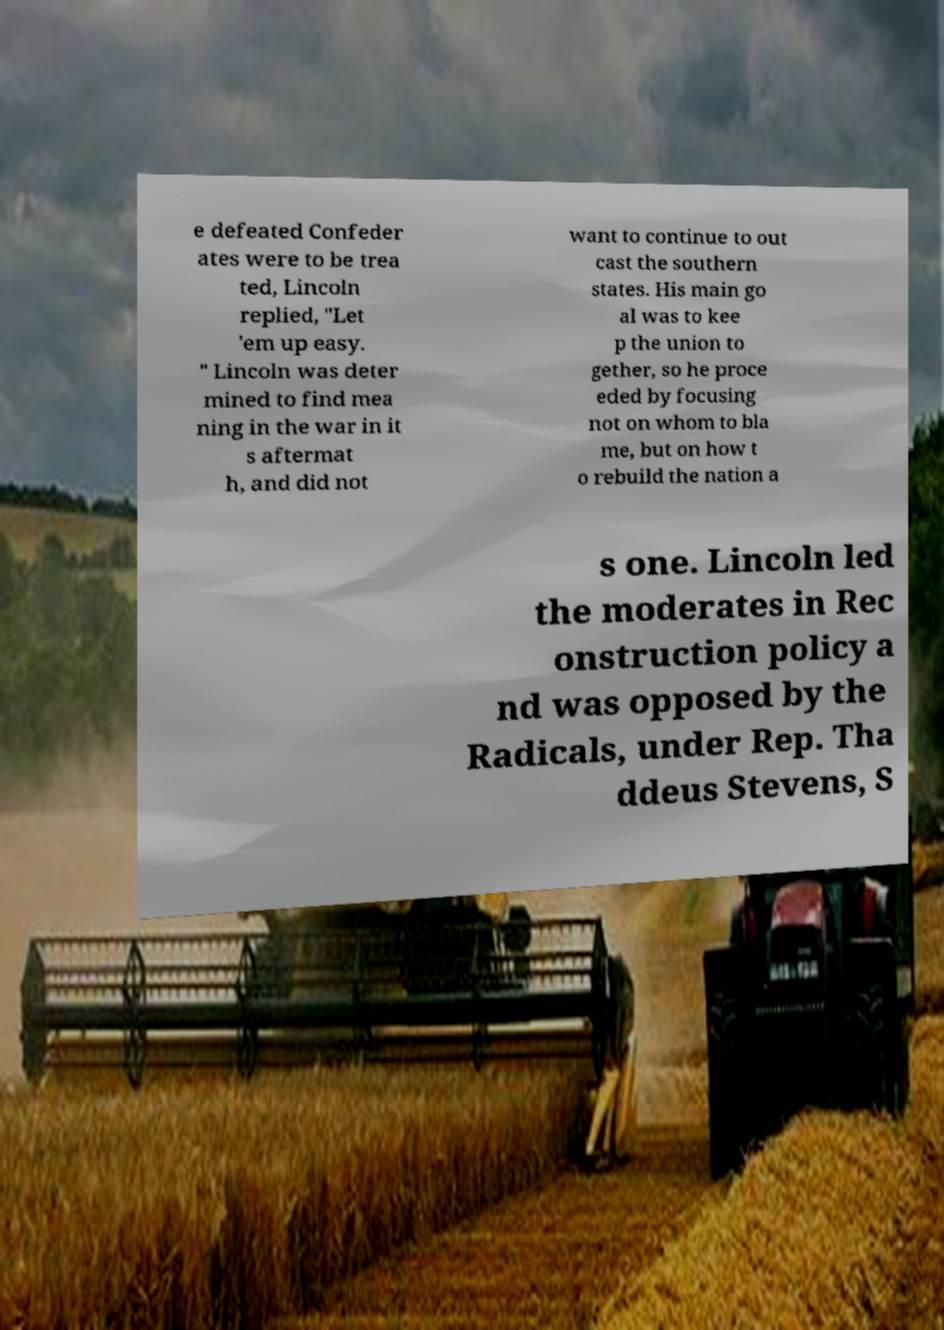Could you assist in decoding the text presented in this image and type it out clearly? e defeated Confeder ates were to be trea ted, Lincoln replied, "Let 'em up easy. " Lincoln was deter mined to find mea ning in the war in it s aftermat h, and did not want to continue to out cast the southern states. His main go al was to kee p the union to gether, so he proce eded by focusing not on whom to bla me, but on how t o rebuild the nation a s one. Lincoln led the moderates in Rec onstruction policy a nd was opposed by the Radicals, under Rep. Tha ddeus Stevens, S 